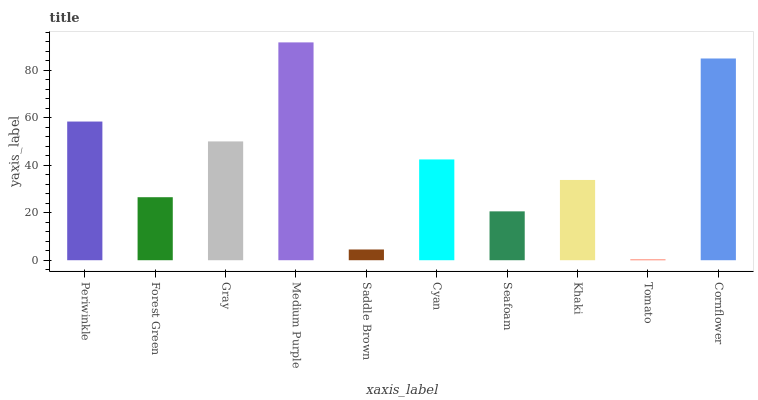Is Tomato the minimum?
Answer yes or no. Yes. Is Medium Purple the maximum?
Answer yes or no. Yes. Is Forest Green the minimum?
Answer yes or no. No. Is Forest Green the maximum?
Answer yes or no. No. Is Periwinkle greater than Forest Green?
Answer yes or no. Yes. Is Forest Green less than Periwinkle?
Answer yes or no. Yes. Is Forest Green greater than Periwinkle?
Answer yes or no. No. Is Periwinkle less than Forest Green?
Answer yes or no. No. Is Cyan the high median?
Answer yes or no. Yes. Is Khaki the low median?
Answer yes or no. Yes. Is Saddle Brown the high median?
Answer yes or no. No. Is Cyan the low median?
Answer yes or no. No. 